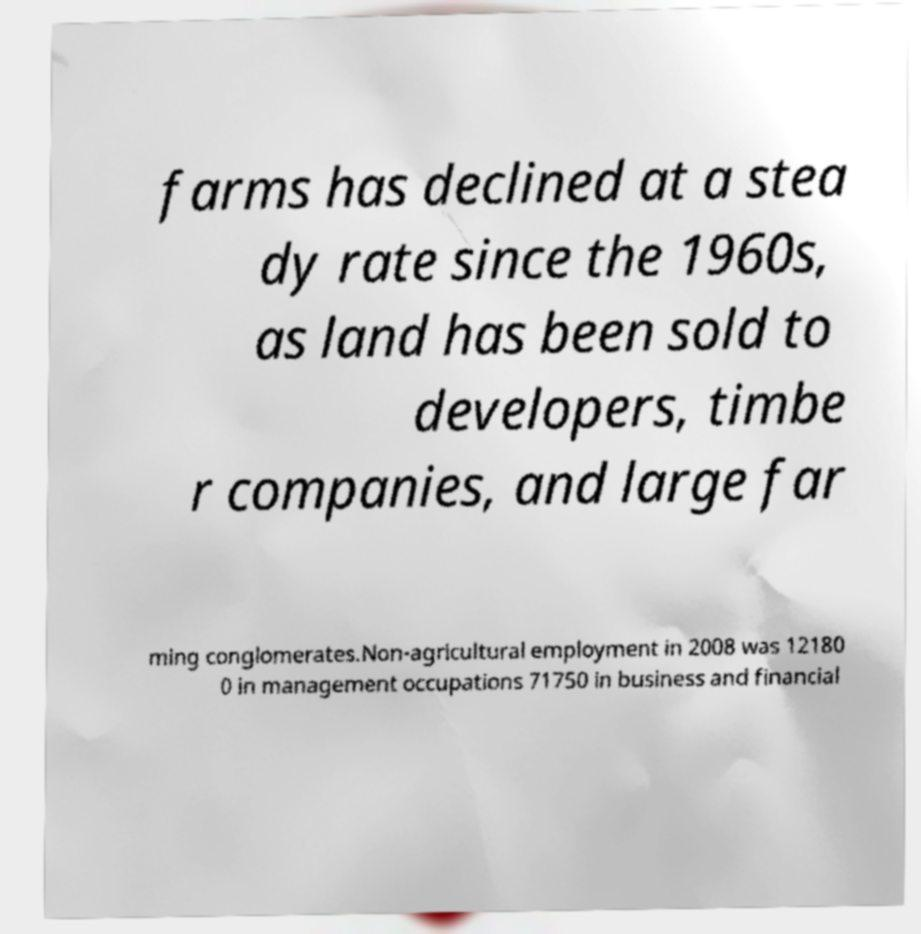Please identify and transcribe the text found in this image. farms has declined at a stea dy rate since the 1960s, as land has been sold to developers, timbe r companies, and large far ming conglomerates.Non-agricultural employment in 2008 was 12180 0 in management occupations 71750 in business and financial 